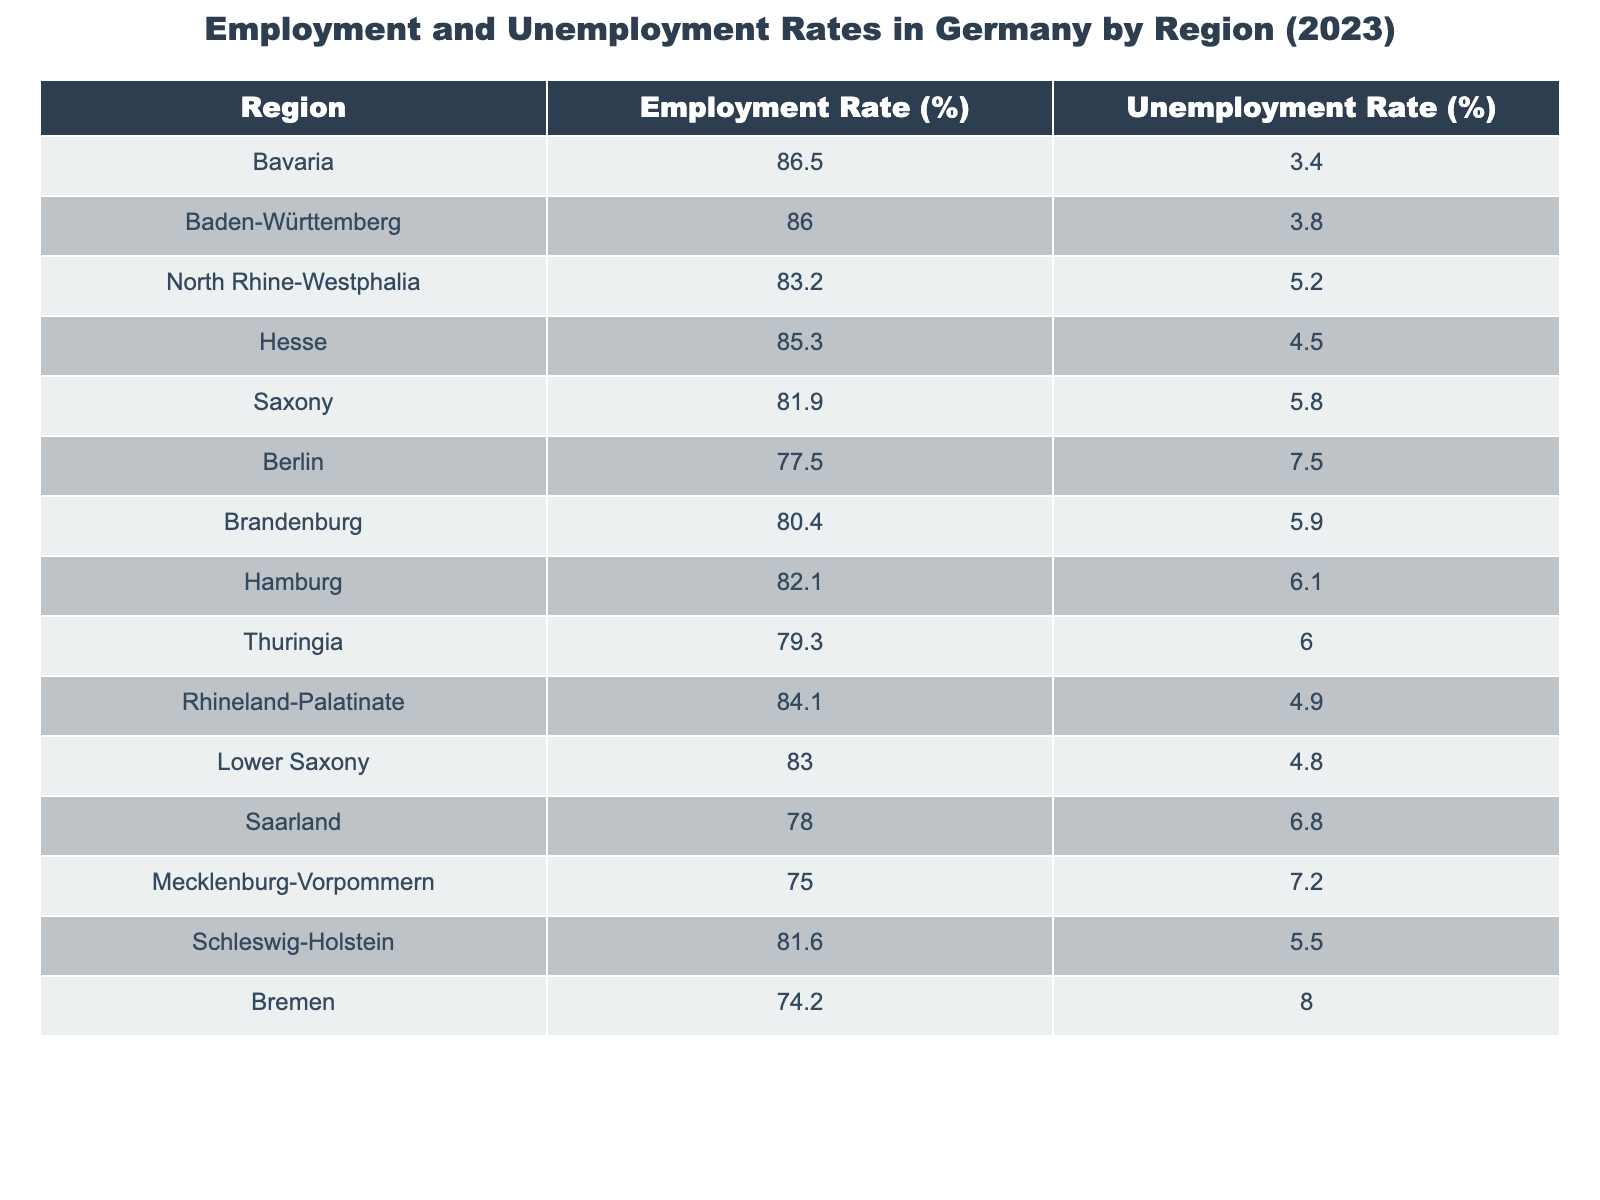What is the employment rate in Bavaria? The employment rate for Bavaria is explicitly stated in the table as 86.5%.
Answer: 86.5% Which region has the highest unemployment rate? Looking at the last column of the table, Bremen has the highest unemployment rate at 8.0%.
Answer: Bremen What is the unemployment rate in Baden-Württemberg? The table specifies that the unemployment rate in Baden-Württemberg is 3.8%.
Answer: 3.8% Which region shows both a high employment rate and a low unemployment rate? Comparing the employment and unemployment rates, Bavaria has the highest employment rate (86.5%) and a low unemployment rate (3.4%).
Answer: Bavaria What is the average employment rate across all regions listed in the table? By summing the employment rates (86.5 + 86.0 + 83.2 + 85.3 + 81.9 + 77.5 + 80.4 + 82.1 + 79.3 + 84.1 + 83.0 + 78.0 + 75.0 + 81.6 + 74.2) which totals to 1261.1, and dividing it by the number of regions (15), the average employment rate is 1261.1 / 15 = 84.07%.
Answer: 84.07% What is the difference in the employment rates between Berlin and Saxony? The employment rate in Berlin is 77.5% and in Saxony is 81.9%, so the difference is 81.9 - 77.5 = 4.4%.
Answer: 4.4% Is it true that all regions have an unemployment rate below 8%? Checking the unemployment rates, only Bremen exceeds 8% at 8.0%. Therefore, the statement is false.
Answer: False Which region has the lowest employment rate? The table indicates that Bremen has the lowest employment rate at 74.2%.
Answer: Bremen What is the total unemployment rate for the regions located in northern Germany (Hamburg, Schleswig-Holstein, Bremen, and Mecklenburg-Vorpommern)? The total unemployment rate can be calculated by summing the unemployment rates of these four regions: 6.1 (Hamburg) + 5.5 (Schleswig-Holstein) + 8.0 (Bremen) + 7.2 (Mecklenburg-Vorpommern) resulting in 26.8%.
Answer: 26.8% If you compare the employment rates of Lower Saxony and Hesse, which is higher? Lower Saxony has an employment rate of 83.0% while Hesse is at 85.3%, indicating Hesse has a higher employment rate.
Answer: Hesse What is the proportion of regions with unemployment rates above 6%? There are 5 regions (Berlin, Hamburg, Saarland, Mecklenburg-Vorpommern, and Bremen) out of 15 that have unemployment rates above 6%. The proportion is 5 / 15, which simplifies to 1/3 or approximately 33.33%.
Answer: 33.33% 